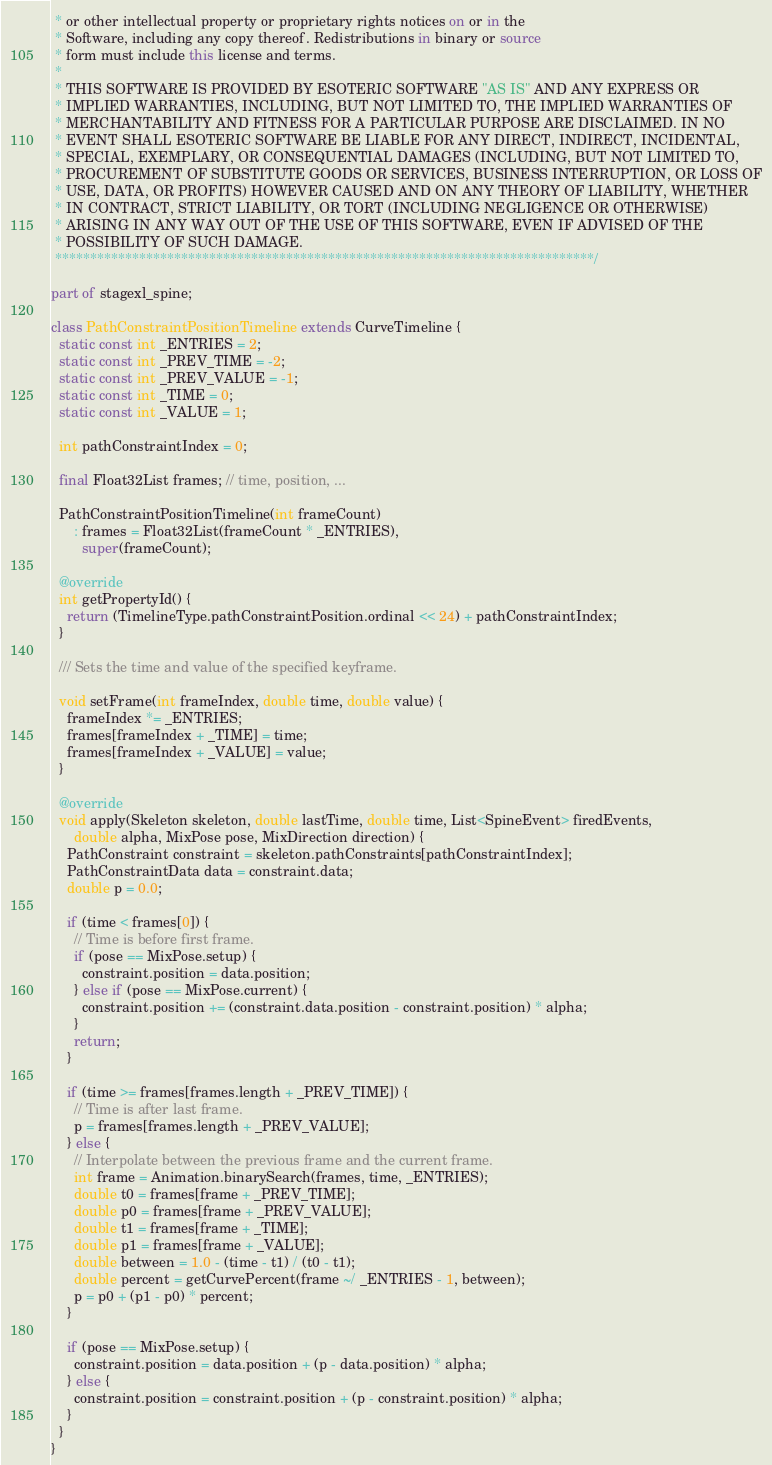Convert code to text. <code><loc_0><loc_0><loc_500><loc_500><_Dart_> * or other intellectual property or proprietary rights notices on or in the
 * Software, including any copy thereof. Redistributions in binary or source
 * form must include this license and terms.
 *
 * THIS SOFTWARE IS PROVIDED BY ESOTERIC SOFTWARE "AS IS" AND ANY EXPRESS OR
 * IMPLIED WARRANTIES, INCLUDING, BUT NOT LIMITED TO, THE IMPLIED WARRANTIES OF
 * MERCHANTABILITY AND FITNESS FOR A PARTICULAR PURPOSE ARE DISCLAIMED. IN NO
 * EVENT SHALL ESOTERIC SOFTWARE BE LIABLE FOR ANY DIRECT, INDIRECT, INCIDENTAL,
 * SPECIAL, EXEMPLARY, OR CONSEQUENTIAL DAMAGES (INCLUDING, BUT NOT LIMITED TO,
 * PROCUREMENT OF SUBSTITUTE GOODS OR SERVICES, BUSINESS INTERRUPTION, OR LOSS OF
 * USE, DATA, OR PROFITS) HOWEVER CAUSED AND ON ANY THEORY OF LIABILITY, WHETHER
 * IN CONTRACT, STRICT LIABILITY, OR TORT (INCLUDING NEGLIGENCE OR OTHERWISE)
 * ARISING IN ANY WAY OUT OF THE USE OF THIS SOFTWARE, EVEN IF ADVISED OF THE
 * POSSIBILITY OF SUCH DAMAGE.
 *****************************************************************************/

part of stagexl_spine;

class PathConstraintPositionTimeline extends CurveTimeline {
  static const int _ENTRIES = 2;
  static const int _PREV_TIME = -2;
  static const int _PREV_VALUE = -1;
  static const int _TIME = 0;
  static const int _VALUE = 1;

  int pathConstraintIndex = 0;

  final Float32List frames; // time, position, ...

  PathConstraintPositionTimeline(int frameCount)
      : frames = Float32List(frameCount * _ENTRIES),
        super(frameCount);

  @override
  int getPropertyId() {
    return (TimelineType.pathConstraintPosition.ordinal << 24) + pathConstraintIndex;
  }

  /// Sets the time and value of the specified keyframe.

  void setFrame(int frameIndex, double time, double value) {
    frameIndex *= _ENTRIES;
    frames[frameIndex + _TIME] = time;
    frames[frameIndex + _VALUE] = value;
  }

  @override
  void apply(Skeleton skeleton, double lastTime, double time, List<SpineEvent> firedEvents,
      double alpha, MixPose pose, MixDirection direction) {
    PathConstraint constraint = skeleton.pathConstraints[pathConstraintIndex];
    PathConstraintData data = constraint.data;
    double p = 0.0;

    if (time < frames[0]) {
      // Time is before first frame.
      if (pose == MixPose.setup) {
        constraint.position = data.position;
      } else if (pose == MixPose.current) {
        constraint.position += (constraint.data.position - constraint.position) * alpha;
      }
      return;
    }

    if (time >= frames[frames.length + _PREV_TIME]) {
      // Time is after last frame.
      p = frames[frames.length + _PREV_VALUE];
    } else {
      // Interpolate between the previous frame and the current frame.
      int frame = Animation.binarySearch(frames, time, _ENTRIES);
      double t0 = frames[frame + _PREV_TIME];
      double p0 = frames[frame + _PREV_VALUE];
      double t1 = frames[frame + _TIME];
      double p1 = frames[frame + _VALUE];
      double between = 1.0 - (time - t1) / (t0 - t1);
      double percent = getCurvePercent(frame ~/ _ENTRIES - 1, between);
      p = p0 + (p1 - p0) * percent;
    }

    if (pose == MixPose.setup) {
      constraint.position = data.position + (p - data.position) * alpha;
    } else {
      constraint.position = constraint.position + (p - constraint.position) * alpha;
    }
  }
}
</code> 